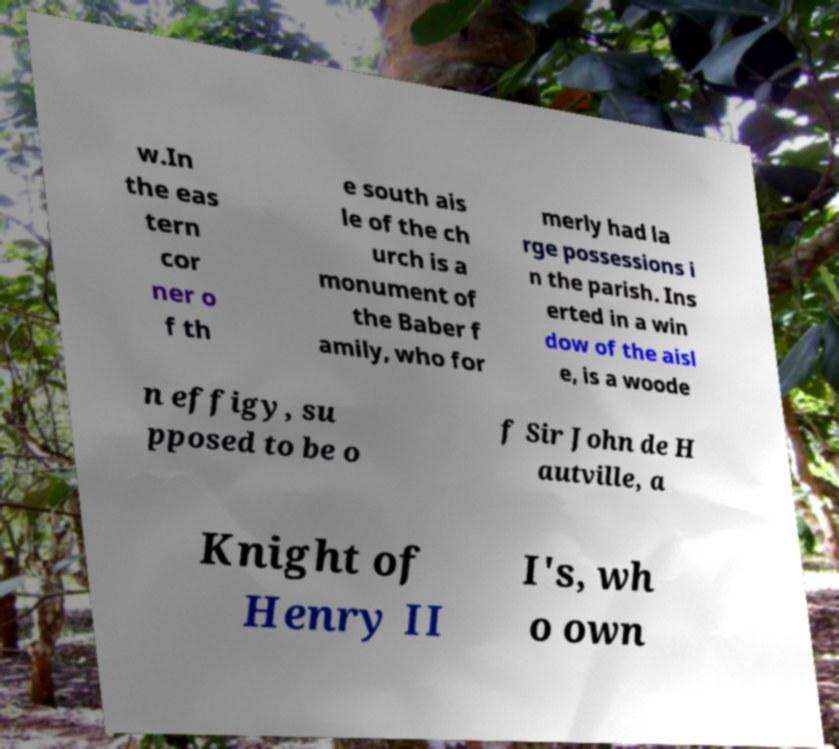For documentation purposes, I need the text within this image transcribed. Could you provide that? w.In the eas tern cor ner o f th e south ais le of the ch urch is a monument of the Baber f amily, who for merly had la rge possessions i n the parish. Ins erted in a win dow of the aisl e, is a woode n effigy, su pposed to be o f Sir John de H autville, a Knight of Henry II I's, wh o own 